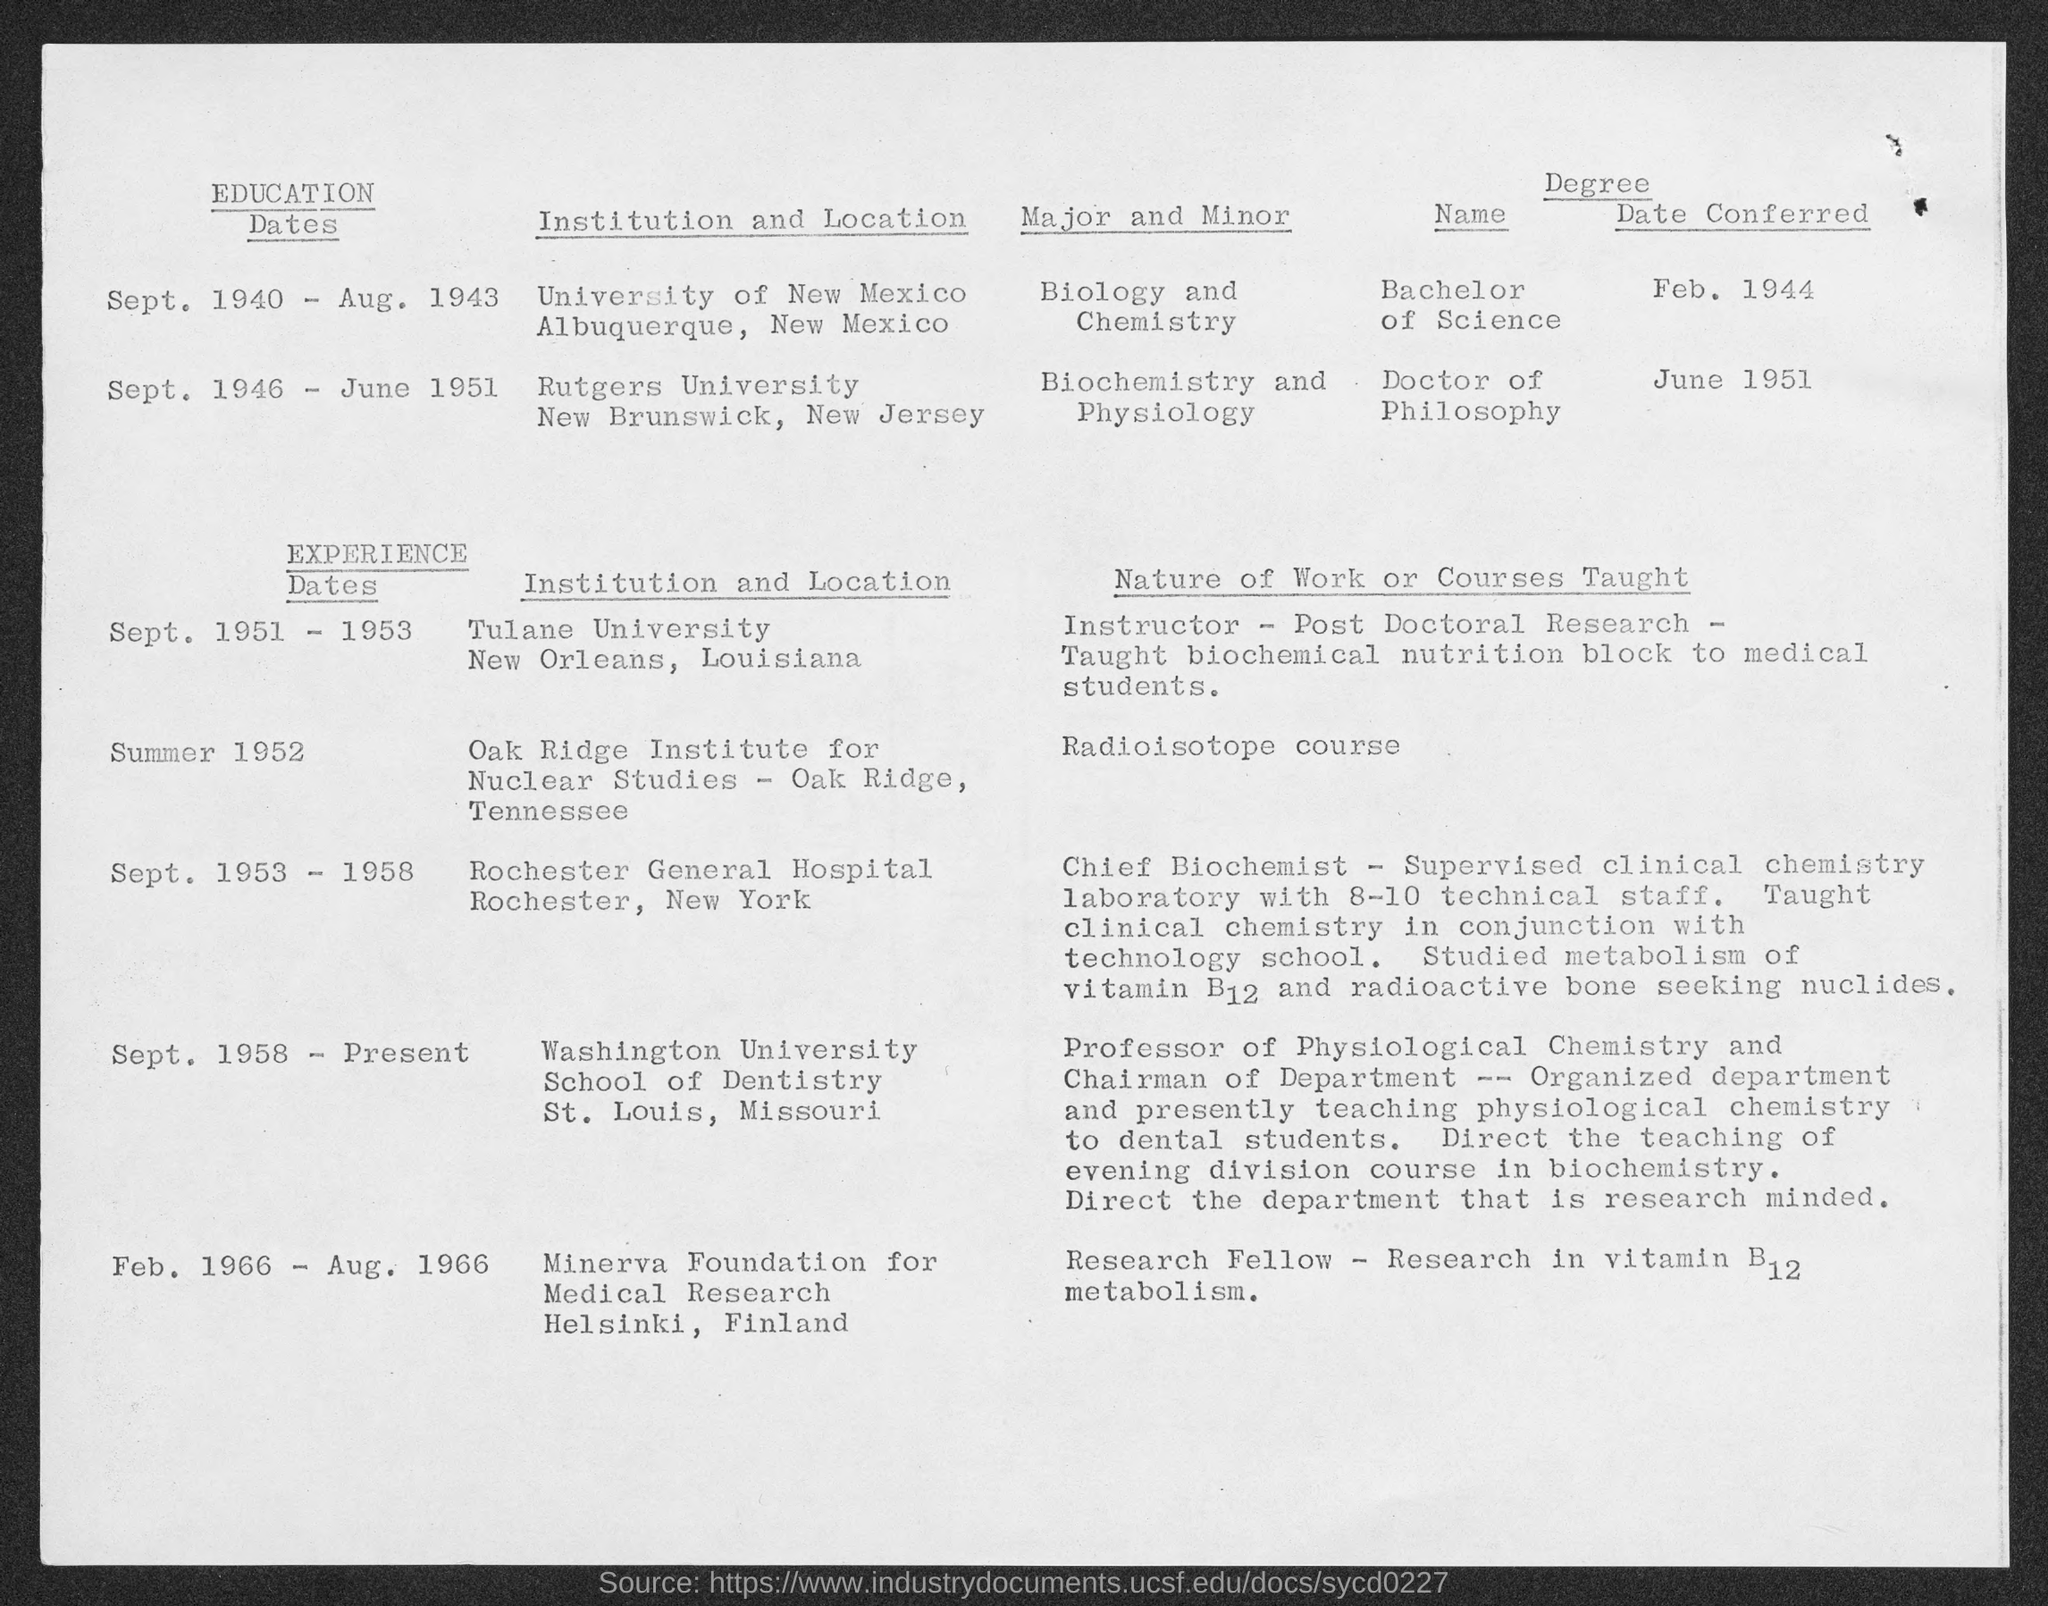Write the Major and Minor Subjects in Rutgers University?
Your response must be concise. Biochemistry and Physiology. 